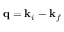Convert formula to latex. <formula><loc_0><loc_0><loc_500><loc_500>q = k _ { i } - k _ { f }</formula> 